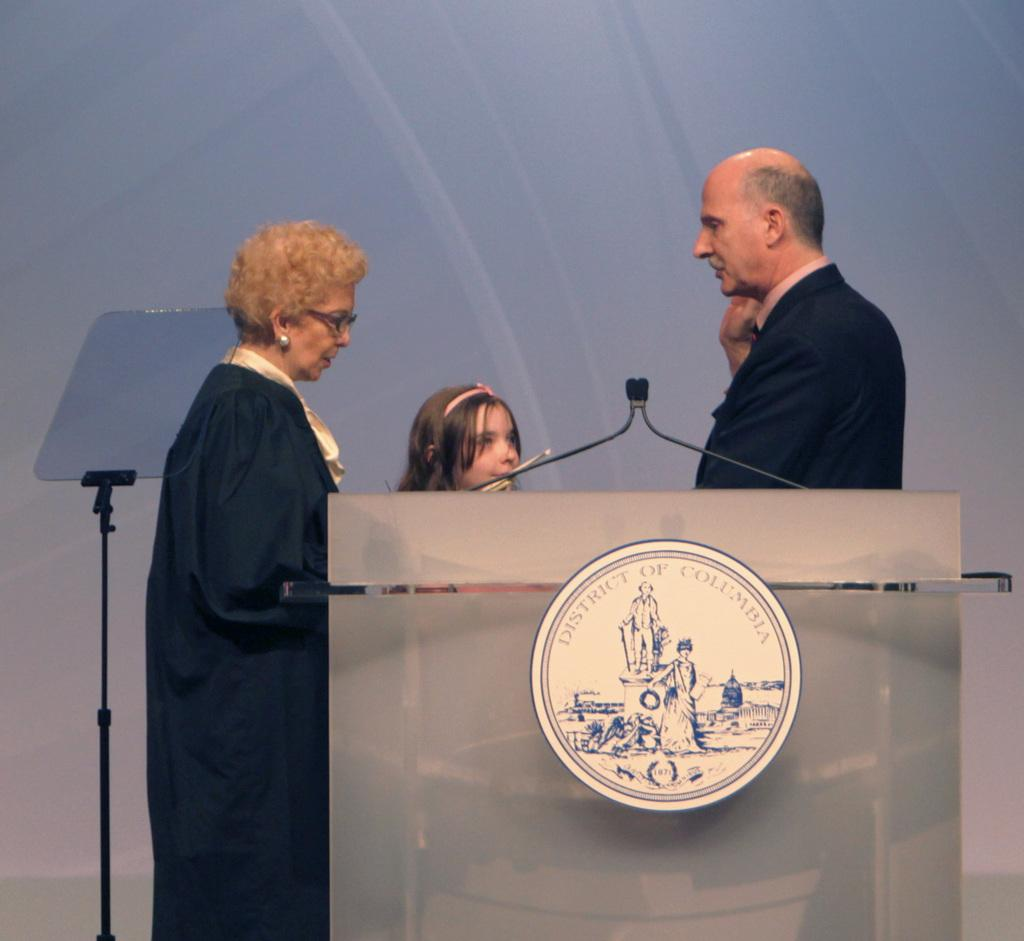How many people are in the image? There are three persons in the image. What are the persons doing in the image? The persons are standing near a podium. What can be seen on the podium? There are microphones on the podium. What other object is visible in the image? There is a stand in the image. What is the current hour according to the clock on the stand in the image? There is no clock visible on the stand in the image, so it is not possible to determine the current hour. 